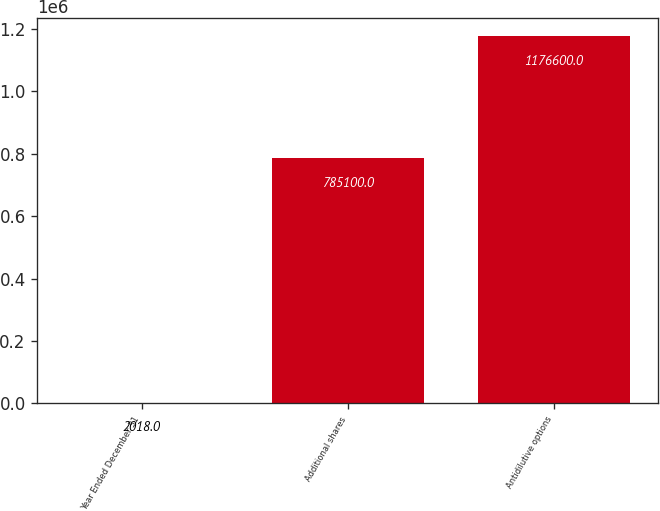<chart> <loc_0><loc_0><loc_500><loc_500><bar_chart><fcel>Year Ended December 31<fcel>Additional shares<fcel>Antidilutive options<nl><fcel>2018<fcel>785100<fcel>1.1766e+06<nl></chart> 